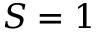<formula> <loc_0><loc_0><loc_500><loc_500>S = 1</formula> 